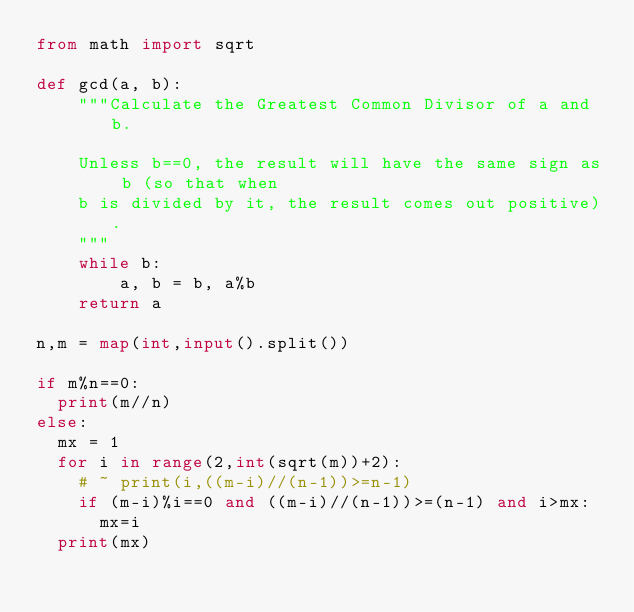Convert code to text. <code><loc_0><loc_0><loc_500><loc_500><_Python_>from math import sqrt

def gcd(a, b):
    """Calculate the Greatest Common Divisor of a and b.

    Unless b==0, the result will have the same sign as b (so that when
    b is divided by it, the result comes out positive).
    """
    while b:
        a, b = b, a%b
    return a

n,m = map(int,input().split())

if m%n==0:
	print(m//n)
else:
	mx = 1
	for i in range(2,int(sqrt(m))+2):
		# ~ print(i,((m-i)//(n-1))>=n-1)
		if (m-i)%i==0 and ((m-i)//(n-1))>=(n-1) and i>mx:
			mx=i
	print(mx)
</code> 